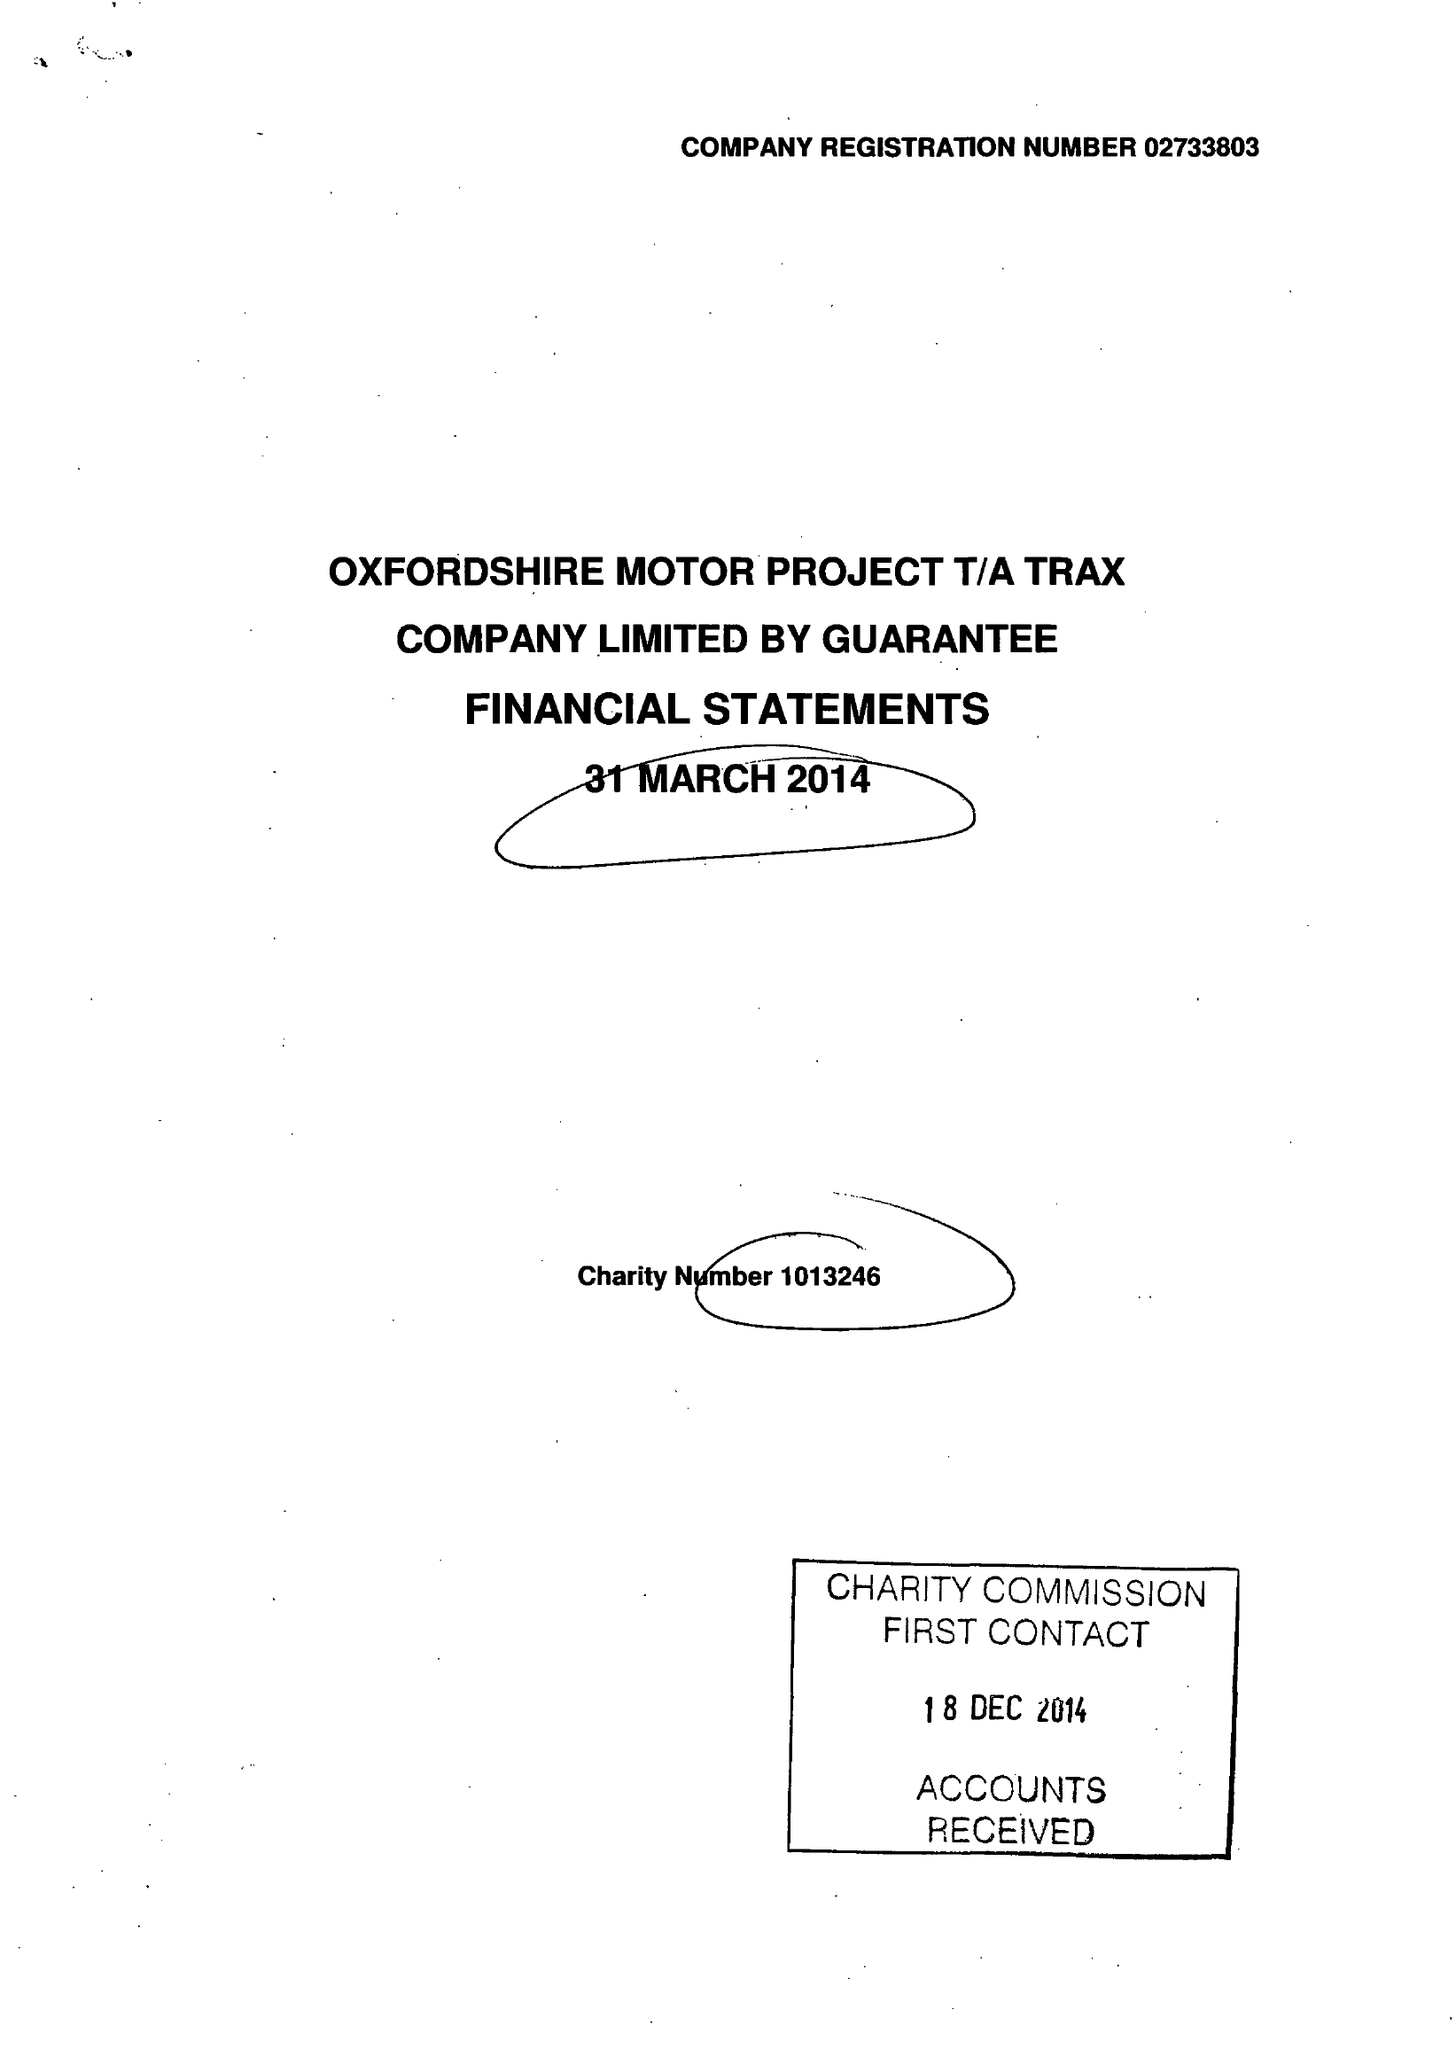What is the value for the address__street_line?
Answer the question using a single word or phrase. WOODSTOCK ROAD 